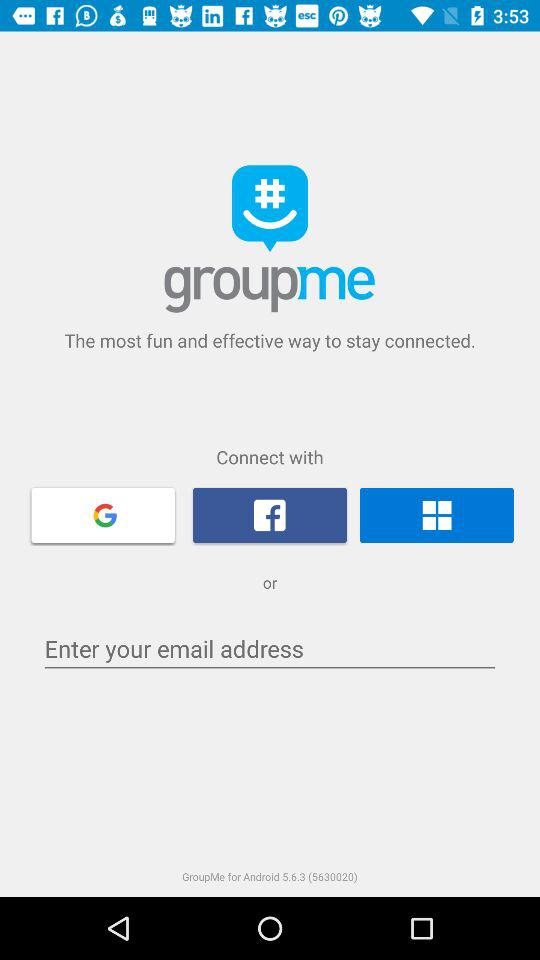What is the application name? The application name is "groupme". 